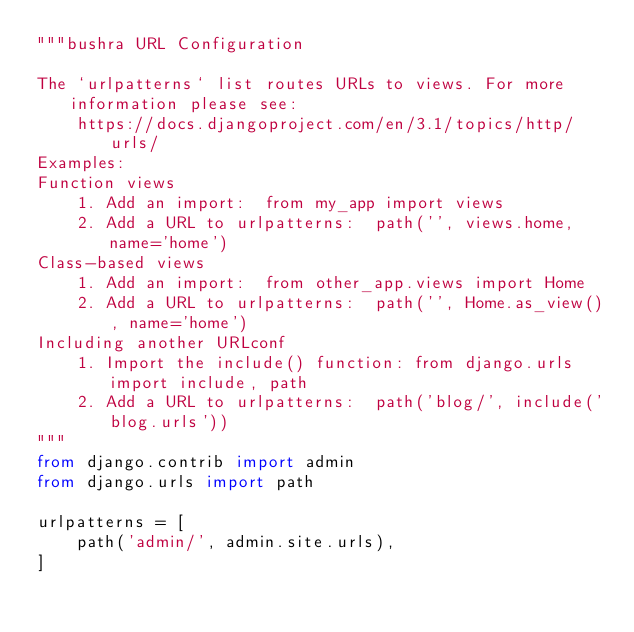<code> <loc_0><loc_0><loc_500><loc_500><_Python_>"""bushra URL Configuration

The `urlpatterns` list routes URLs to views. For more information please see:
    https://docs.djangoproject.com/en/3.1/topics/http/urls/
Examples:
Function views
    1. Add an import:  from my_app import views
    2. Add a URL to urlpatterns:  path('', views.home, name='home')
Class-based views
    1. Add an import:  from other_app.views import Home
    2. Add a URL to urlpatterns:  path('', Home.as_view(), name='home')
Including another URLconf
    1. Import the include() function: from django.urls import include, path
    2. Add a URL to urlpatterns:  path('blog/', include('blog.urls'))
"""
from django.contrib import admin
from django.urls import path

urlpatterns = [
    path('admin/', admin.site.urls),
]
</code> 